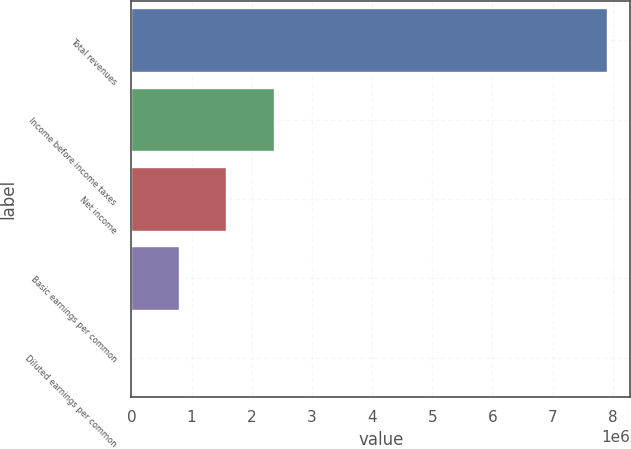<chart> <loc_0><loc_0><loc_500><loc_500><bar_chart><fcel>Total revenues<fcel>Income before income taxes<fcel>Net income<fcel>Basic earnings per common<fcel>Diluted earnings per common<nl><fcel>7.89889e+06<fcel>2.36967e+06<fcel>1.57978e+06<fcel>789890<fcel>1.67<nl></chart> 